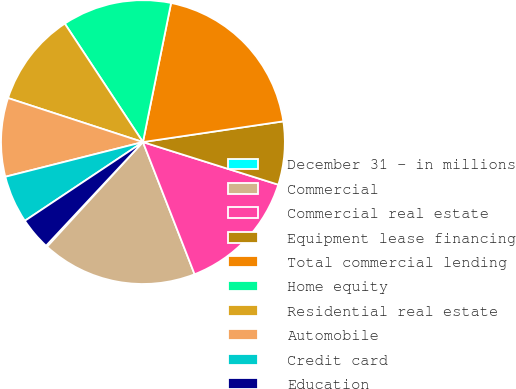Convert chart. <chart><loc_0><loc_0><loc_500><loc_500><pie_chart><fcel>December 31 - in millions<fcel>Commercial<fcel>Commercial real estate<fcel>Equipment lease financing<fcel>Total commercial lending<fcel>Home equity<fcel>Residential real estate<fcel>Automobile<fcel>Credit card<fcel>Education<nl><fcel>0.16%<fcel>17.73%<fcel>14.22%<fcel>7.19%<fcel>19.49%<fcel>12.46%<fcel>10.7%<fcel>8.95%<fcel>5.43%<fcel>3.68%<nl></chart> 